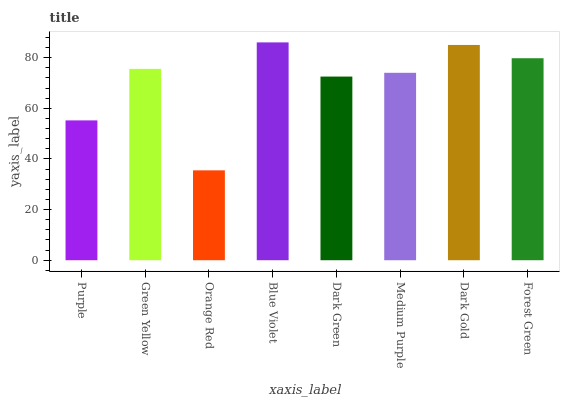Is Green Yellow the minimum?
Answer yes or no. No. Is Green Yellow the maximum?
Answer yes or no. No. Is Green Yellow greater than Purple?
Answer yes or no. Yes. Is Purple less than Green Yellow?
Answer yes or no. Yes. Is Purple greater than Green Yellow?
Answer yes or no. No. Is Green Yellow less than Purple?
Answer yes or no. No. Is Green Yellow the high median?
Answer yes or no. Yes. Is Medium Purple the low median?
Answer yes or no. Yes. Is Medium Purple the high median?
Answer yes or no. No. Is Blue Violet the low median?
Answer yes or no. No. 